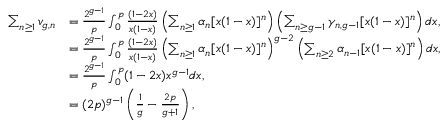<formula> <loc_0><loc_0><loc_500><loc_500>\begin{array} { r l } { \sum _ { n \geq 1 } v _ { g , n } } & { = \frac { 2 ^ { g - 1 } } { p } \int _ { 0 } ^ { p } \frac { ( 1 - 2 x ) } { x ( 1 - x ) } \left ( \sum _ { n \geq 1 } \alpha _ { n } [ x ( 1 - x ) ] ^ { n } \right ) \left ( \sum _ { n \geq g - 1 } \gamma _ { n , g - 1 } [ x ( 1 - x ) ] ^ { n } \right ) d x , } \\ & { = \frac { 2 ^ { g - 1 } } { p } \int _ { 0 } ^ { p } \frac { ( 1 - 2 x ) } { x ( 1 - x ) } \left ( \sum _ { n \geq 1 } \alpha _ { n } [ x ( 1 - x ) ] ^ { n } \right ) ^ { g - 2 } \left ( \sum _ { n \geq 2 } \alpha _ { n - 1 } [ x ( 1 - x ) ] ^ { n } \right ) d x , } \\ & { = \frac { 2 ^ { g - 1 } } { p } \int _ { 0 } ^ { p } ( 1 - 2 x ) x ^ { g - 1 } d x , } \\ & { = ( 2 p ) ^ { g - 1 } \left ( \frac { 1 } { g } - \frac { 2 p } { g + 1 } \right ) , } \end{array}</formula> 